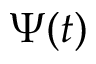<formula> <loc_0><loc_0><loc_500><loc_500>\Psi ( t )</formula> 